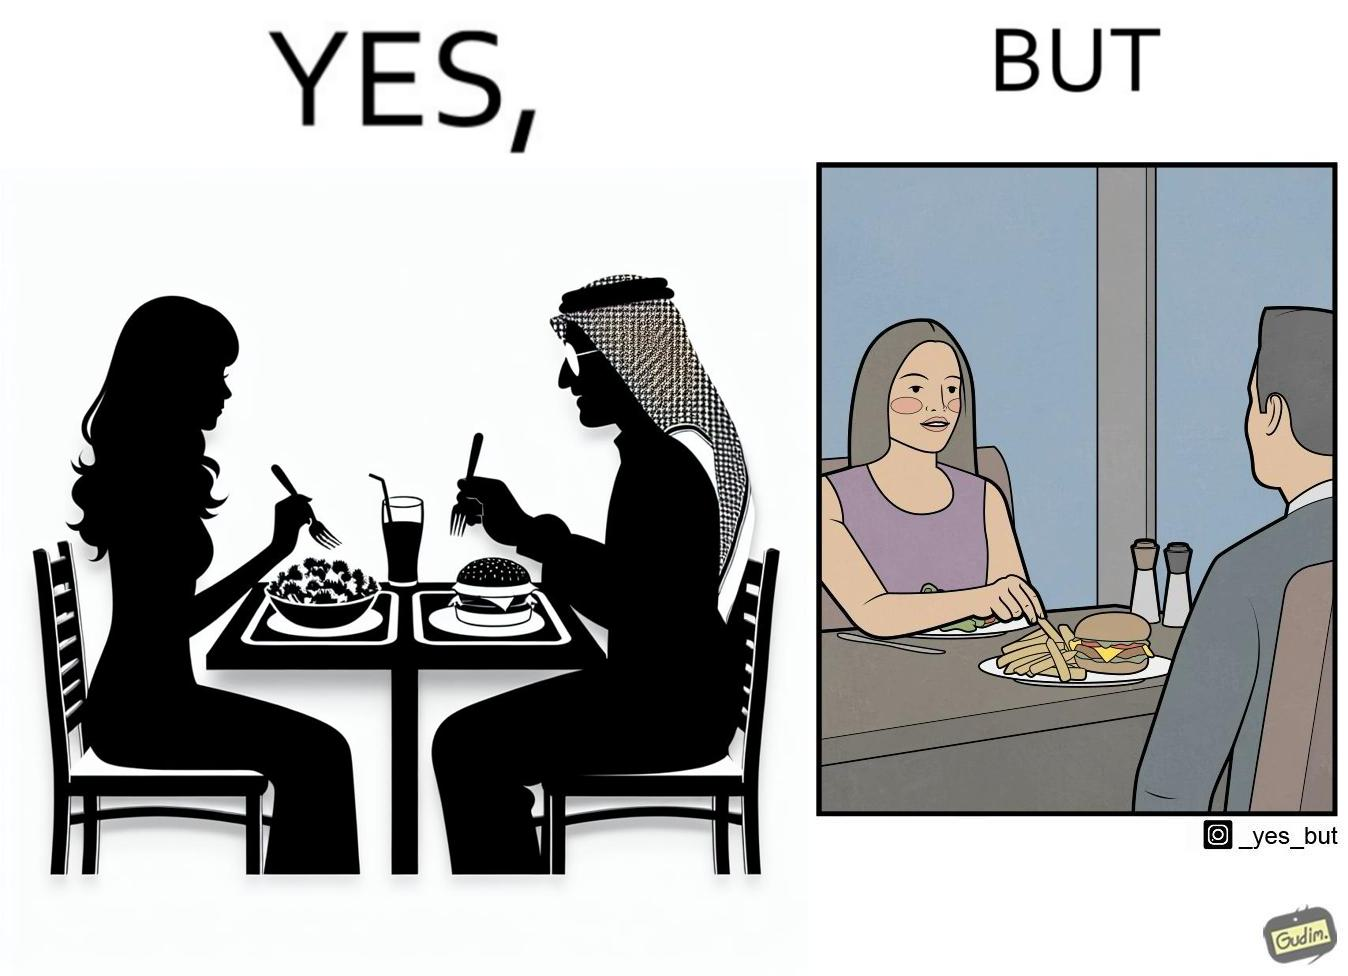Describe what you see in the left and right parts of this image. In the left part of the image: a woman and a man having their meals at some restaurant, with a plate of salad on the woman's side and a burger and french fries on the man's side on the table In the right part of the image: a woman and a man having their meals at some restaurant, with a plate of salad on the woman's side and a burger and french fries on the man's side on the table and the woman is having the french fries from the man's plate 